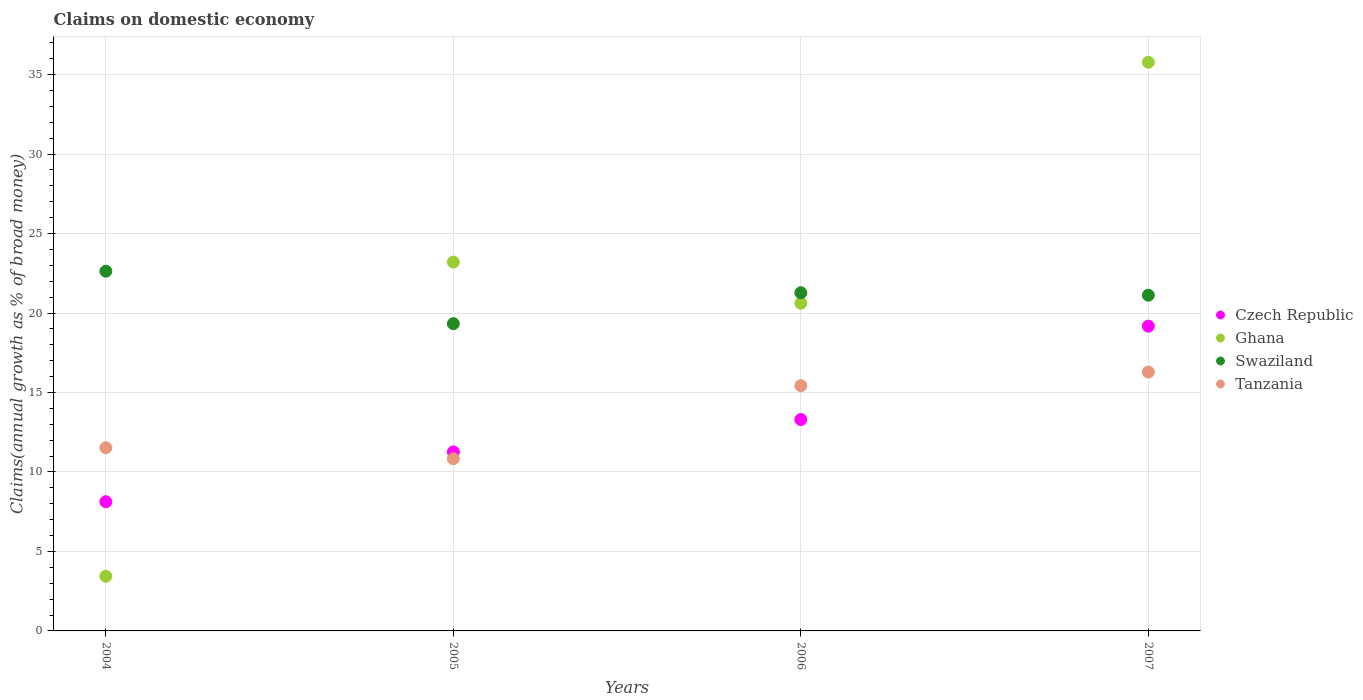How many different coloured dotlines are there?
Ensure brevity in your answer.  4. What is the percentage of broad money claimed on domestic economy in Ghana in 2007?
Your answer should be compact. 35.77. Across all years, what is the maximum percentage of broad money claimed on domestic economy in Tanzania?
Give a very brief answer. 16.29. Across all years, what is the minimum percentage of broad money claimed on domestic economy in Tanzania?
Your answer should be very brief. 10.83. What is the total percentage of broad money claimed on domestic economy in Ghana in the graph?
Provide a short and direct response. 83.03. What is the difference between the percentage of broad money claimed on domestic economy in Ghana in 2005 and that in 2006?
Provide a short and direct response. 2.59. What is the difference between the percentage of broad money claimed on domestic economy in Swaziland in 2006 and the percentage of broad money claimed on domestic economy in Czech Republic in 2004?
Your answer should be very brief. 13.15. What is the average percentage of broad money claimed on domestic economy in Swaziland per year?
Offer a very short reply. 21.09. In the year 2007, what is the difference between the percentage of broad money claimed on domestic economy in Ghana and percentage of broad money claimed on domestic economy in Swaziland?
Keep it short and to the point. 14.65. What is the ratio of the percentage of broad money claimed on domestic economy in Tanzania in 2005 to that in 2006?
Make the answer very short. 0.7. Is the difference between the percentage of broad money claimed on domestic economy in Ghana in 2004 and 2005 greater than the difference between the percentage of broad money claimed on domestic economy in Swaziland in 2004 and 2005?
Make the answer very short. No. What is the difference between the highest and the second highest percentage of broad money claimed on domestic economy in Czech Republic?
Offer a terse response. 5.87. What is the difference between the highest and the lowest percentage of broad money claimed on domestic economy in Czech Republic?
Ensure brevity in your answer.  11.05. In how many years, is the percentage of broad money claimed on domestic economy in Czech Republic greater than the average percentage of broad money claimed on domestic economy in Czech Republic taken over all years?
Offer a very short reply. 2. Is the sum of the percentage of broad money claimed on domestic economy in Tanzania in 2004 and 2006 greater than the maximum percentage of broad money claimed on domestic economy in Czech Republic across all years?
Offer a very short reply. Yes. Is it the case that in every year, the sum of the percentage of broad money claimed on domestic economy in Tanzania and percentage of broad money claimed on domestic economy in Swaziland  is greater than the percentage of broad money claimed on domestic economy in Ghana?
Provide a succinct answer. Yes. Is the percentage of broad money claimed on domestic economy in Tanzania strictly less than the percentage of broad money claimed on domestic economy in Czech Republic over the years?
Your response must be concise. No. What is the difference between two consecutive major ticks on the Y-axis?
Your answer should be compact. 5. Are the values on the major ticks of Y-axis written in scientific E-notation?
Provide a short and direct response. No. Does the graph contain any zero values?
Offer a very short reply. No. How many legend labels are there?
Offer a terse response. 4. How are the legend labels stacked?
Your response must be concise. Vertical. What is the title of the graph?
Provide a short and direct response. Claims on domestic economy. Does "East Asia (developing only)" appear as one of the legend labels in the graph?
Keep it short and to the point. No. What is the label or title of the X-axis?
Your answer should be very brief. Years. What is the label or title of the Y-axis?
Ensure brevity in your answer.  Claims(annual growth as % of broad money). What is the Claims(annual growth as % of broad money) in Czech Republic in 2004?
Your response must be concise. 8.13. What is the Claims(annual growth as % of broad money) in Ghana in 2004?
Give a very brief answer. 3.44. What is the Claims(annual growth as % of broad money) of Swaziland in 2004?
Give a very brief answer. 22.63. What is the Claims(annual growth as % of broad money) in Tanzania in 2004?
Your answer should be very brief. 11.52. What is the Claims(annual growth as % of broad money) in Czech Republic in 2005?
Provide a succinct answer. 11.26. What is the Claims(annual growth as % of broad money) in Ghana in 2005?
Ensure brevity in your answer.  23.2. What is the Claims(annual growth as % of broad money) of Swaziland in 2005?
Ensure brevity in your answer.  19.33. What is the Claims(annual growth as % of broad money) of Tanzania in 2005?
Your answer should be compact. 10.83. What is the Claims(annual growth as % of broad money) of Czech Republic in 2006?
Give a very brief answer. 13.3. What is the Claims(annual growth as % of broad money) of Ghana in 2006?
Offer a very short reply. 20.62. What is the Claims(annual growth as % of broad money) in Swaziland in 2006?
Provide a succinct answer. 21.27. What is the Claims(annual growth as % of broad money) of Tanzania in 2006?
Offer a very short reply. 15.43. What is the Claims(annual growth as % of broad money) in Czech Republic in 2007?
Offer a terse response. 19.17. What is the Claims(annual growth as % of broad money) in Ghana in 2007?
Make the answer very short. 35.77. What is the Claims(annual growth as % of broad money) in Swaziland in 2007?
Give a very brief answer. 21.12. What is the Claims(annual growth as % of broad money) in Tanzania in 2007?
Your answer should be very brief. 16.29. Across all years, what is the maximum Claims(annual growth as % of broad money) of Czech Republic?
Your response must be concise. 19.17. Across all years, what is the maximum Claims(annual growth as % of broad money) of Ghana?
Your answer should be very brief. 35.77. Across all years, what is the maximum Claims(annual growth as % of broad money) in Swaziland?
Provide a short and direct response. 22.63. Across all years, what is the maximum Claims(annual growth as % of broad money) of Tanzania?
Provide a succinct answer. 16.29. Across all years, what is the minimum Claims(annual growth as % of broad money) in Czech Republic?
Your response must be concise. 8.13. Across all years, what is the minimum Claims(annual growth as % of broad money) of Ghana?
Give a very brief answer. 3.44. Across all years, what is the minimum Claims(annual growth as % of broad money) in Swaziland?
Your answer should be very brief. 19.33. Across all years, what is the minimum Claims(annual growth as % of broad money) in Tanzania?
Your answer should be compact. 10.83. What is the total Claims(annual growth as % of broad money) in Czech Republic in the graph?
Your answer should be very brief. 51.86. What is the total Claims(annual growth as % of broad money) of Ghana in the graph?
Make the answer very short. 83.03. What is the total Claims(annual growth as % of broad money) of Swaziland in the graph?
Offer a very short reply. 84.35. What is the total Claims(annual growth as % of broad money) in Tanzania in the graph?
Your answer should be compact. 54.07. What is the difference between the Claims(annual growth as % of broad money) in Czech Republic in 2004 and that in 2005?
Make the answer very short. -3.14. What is the difference between the Claims(annual growth as % of broad money) in Ghana in 2004 and that in 2005?
Keep it short and to the point. -19.76. What is the difference between the Claims(annual growth as % of broad money) in Swaziland in 2004 and that in 2005?
Provide a succinct answer. 3.3. What is the difference between the Claims(annual growth as % of broad money) of Tanzania in 2004 and that in 2005?
Offer a very short reply. 0.69. What is the difference between the Claims(annual growth as % of broad money) of Czech Republic in 2004 and that in 2006?
Ensure brevity in your answer.  -5.17. What is the difference between the Claims(annual growth as % of broad money) of Ghana in 2004 and that in 2006?
Offer a terse response. -17.18. What is the difference between the Claims(annual growth as % of broad money) in Swaziland in 2004 and that in 2006?
Ensure brevity in your answer.  1.35. What is the difference between the Claims(annual growth as % of broad money) in Tanzania in 2004 and that in 2006?
Give a very brief answer. -3.91. What is the difference between the Claims(annual growth as % of broad money) in Czech Republic in 2004 and that in 2007?
Your answer should be very brief. -11.05. What is the difference between the Claims(annual growth as % of broad money) in Ghana in 2004 and that in 2007?
Your answer should be very brief. -32.33. What is the difference between the Claims(annual growth as % of broad money) in Swaziland in 2004 and that in 2007?
Your answer should be very brief. 1.51. What is the difference between the Claims(annual growth as % of broad money) of Tanzania in 2004 and that in 2007?
Offer a terse response. -4.76. What is the difference between the Claims(annual growth as % of broad money) in Czech Republic in 2005 and that in 2006?
Make the answer very short. -2.04. What is the difference between the Claims(annual growth as % of broad money) of Ghana in 2005 and that in 2006?
Provide a short and direct response. 2.59. What is the difference between the Claims(annual growth as % of broad money) of Swaziland in 2005 and that in 2006?
Provide a succinct answer. -1.95. What is the difference between the Claims(annual growth as % of broad money) of Tanzania in 2005 and that in 2006?
Make the answer very short. -4.6. What is the difference between the Claims(annual growth as % of broad money) in Czech Republic in 2005 and that in 2007?
Give a very brief answer. -7.91. What is the difference between the Claims(annual growth as % of broad money) in Ghana in 2005 and that in 2007?
Offer a very short reply. -12.57. What is the difference between the Claims(annual growth as % of broad money) of Swaziland in 2005 and that in 2007?
Ensure brevity in your answer.  -1.79. What is the difference between the Claims(annual growth as % of broad money) in Tanzania in 2005 and that in 2007?
Keep it short and to the point. -5.46. What is the difference between the Claims(annual growth as % of broad money) in Czech Republic in 2006 and that in 2007?
Offer a very short reply. -5.87. What is the difference between the Claims(annual growth as % of broad money) in Ghana in 2006 and that in 2007?
Provide a short and direct response. -15.16. What is the difference between the Claims(annual growth as % of broad money) in Swaziland in 2006 and that in 2007?
Ensure brevity in your answer.  0.15. What is the difference between the Claims(annual growth as % of broad money) in Tanzania in 2006 and that in 2007?
Provide a succinct answer. -0.86. What is the difference between the Claims(annual growth as % of broad money) of Czech Republic in 2004 and the Claims(annual growth as % of broad money) of Ghana in 2005?
Your response must be concise. -15.08. What is the difference between the Claims(annual growth as % of broad money) in Czech Republic in 2004 and the Claims(annual growth as % of broad money) in Swaziland in 2005?
Provide a short and direct response. -11.2. What is the difference between the Claims(annual growth as % of broad money) in Czech Republic in 2004 and the Claims(annual growth as % of broad money) in Tanzania in 2005?
Provide a short and direct response. -2.7. What is the difference between the Claims(annual growth as % of broad money) in Ghana in 2004 and the Claims(annual growth as % of broad money) in Swaziland in 2005?
Make the answer very short. -15.89. What is the difference between the Claims(annual growth as % of broad money) of Ghana in 2004 and the Claims(annual growth as % of broad money) of Tanzania in 2005?
Your response must be concise. -7.39. What is the difference between the Claims(annual growth as % of broad money) of Swaziland in 2004 and the Claims(annual growth as % of broad money) of Tanzania in 2005?
Your answer should be very brief. 11.8. What is the difference between the Claims(annual growth as % of broad money) in Czech Republic in 2004 and the Claims(annual growth as % of broad money) in Ghana in 2006?
Provide a succinct answer. -12.49. What is the difference between the Claims(annual growth as % of broad money) in Czech Republic in 2004 and the Claims(annual growth as % of broad money) in Swaziland in 2006?
Give a very brief answer. -13.15. What is the difference between the Claims(annual growth as % of broad money) of Czech Republic in 2004 and the Claims(annual growth as % of broad money) of Tanzania in 2006?
Keep it short and to the point. -7.3. What is the difference between the Claims(annual growth as % of broad money) in Ghana in 2004 and the Claims(annual growth as % of broad money) in Swaziland in 2006?
Offer a terse response. -17.84. What is the difference between the Claims(annual growth as % of broad money) of Ghana in 2004 and the Claims(annual growth as % of broad money) of Tanzania in 2006?
Offer a very short reply. -11.99. What is the difference between the Claims(annual growth as % of broad money) of Swaziland in 2004 and the Claims(annual growth as % of broad money) of Tanzania in 2006?
Provide a succinct answer. 7.2. What is the difference between the Claims(annual growth as % of broad money) in Czech Republic in 2004 and the Claims(annual growth as % of broad money) in Ghana in 2007?
Provide a succinct answer. -27.65. What is the difference between the Claims(annual growth as % of broad money) of Czech Republic in 2004 and the Claims(annual growth as % of broad money) of Swaziland in 2007?
Provide a short and direct response. -12.99. What is the difference between the Claims(annual growth as % of broad money) in Czech Republic in 2004 and the Claims(annual growth as % of broad money) in Tanzania in 2007?
Give a very brief answer. -8.16. What is the difference between the Claims(annual growth as % of broad money) in Ghana in 2004 and the Claims(annual growth as % of broad money) in Swaziland in 2007?
Give a very brief answer. -17.68. What is the difference between the Claims(annual growth as % of broad money) of Ghana in 2004 and the Claims(annual growth as % of broad money) of Tanzania in 2007?
Give a very brief answer. -12.85. What is the difference between the Claims(annual growth as % of broad money) in Swaziland in 2004 and the Claims(annual growth as % of broad money) in Tanzania in 2007?
Your response must be concise. 6.34. What is the difference between the Claims(annual growth as % of broad money) of Czech Republic in 2005 and the Claims(annual growth as % of broad money) of Ghana in 2006?
Provide a short and direct response. -9.36. What is the difference between the Claims(annual growth as % of broad money) of Czech Republic in 2005 and the Claims(annual growth as % of broad money) of Swaziland in 2006?
Provide a succinct answer. -10.01. What is the difference between the Claims(annual growth as % of broad money) in Czech Republic in 2005 and the Claims(annual growth as % of broad money) in Tanzania in 2006?
Give a very brief answer. -4.17. What is the difference between the Claims(annual growth as % of broad money) of Ghana in 2005 and the Claims(annual growth as % of broad money) of Swaziland in 2006?
Make the answer very short. 1.93. What is the difference between the Claims(annual growth as % of broad money) of Ghana in 2005 and the Claims(annual growth as % of broad money) of Tanzania in 2006?
Ensure brevity in your answer.  7.77. What is the difference between the Claims(annual growth as % of broad money) in Swaziland in 2005 and the Claims(annual growth as % of broad money) in Tanzania in 2006?
Offer a terse response. 3.9. What is the difference between the Claims(annual growth as % of broad money) in Czech Republic in 2005 and the Claims(annual growth as % of broad money) in Ghana in 2007?
Keep it short and to the point. -24.51. What is the difference between the Claims(annual growth as % of broad money) in Czech Republic in 2005 and the Claims(annual growth as % of broad money) in Swaziland in 2007?
Give a very brief answer. -9.86. What is the difference between the Claims(annual growth as % of broad money) in Czech Republic in 2005 and the Claims(annual growth as % of broad money) in Tanzania in 2007?
Ensure brevity in your answer.  -5.02. What is the difference between the Claims(annual growth as % of broad money) of Ghana in 2005 and the Claims(annual growth as % of broad money) of Swaziland in 2007?
Your answer should be compact. 2.08. What is the difference between the Claims(annual growth as % of broad money) in Ghana in 2005 and the Claims(annual growth as % of broad money) in Tanzania in 2007?
Make the answer very short. 6.92. What is the difference between the Claims(annual growth as % of broad money) of Swaziland in 2005 and the Claims(annual growth as % of broad money) of Tanzania in 2007?
Your answer should be very brief. 3.04. What is the difference between the Claims(annual growth as % of broad money) in Czech Republic in 2006 and the Claims(annual growth as % of broad money) in Ghana in 2007?
Ensure brevity in your answer.  -22.47. What is the difference between the Claims(annual growth as % of broad money) of Czech Republic in 2006 and the Claims(annual growth as % of broad money) of Swaziland in 2007?
Provide a short and direct response. -7.82. What is the difference between the Claims(annual growth as % of broad money) in Czech Republic in 2006 and the Claims(annual growth as % of broad money) in Tanzania in 2007?
Your answer should be very brief. -2.99. What is the difference between the Claims(annual growth as % of broad money) of Ghana in 2006 and the Claims(annual growth as % of broad money) of Swaziland in 2007?
Provide a short and direct response. -0.5. What is the difference between the Claims(annual growth as % of broad money) in Ghana in 2006 and the Claims(annual growth as % of broad money) in Tanzania in 2007?
Give a very brief answer. 4.33. What is the difference between the Claims(annual growth as % of broad money) in Swaziland in 2006 and the Claims(annual growth as % of broad money) in Tanzania in 2007?
Make the answer very short. 4.99. What is the average Claims(annual growth as % of broad money) in Czech Republic per year?
Your answer should be very brief. 12.96. What is the average Claims(annual growth as % of broad money) of Ghana per year?
Offer a very short reply. 20.76. What is the average Claims(annual growth as % of broad money) in Swaziland per year?
Your response must be concise. 21.09. What is the average Claims(annual growth as % of broad money) of Tanzania per year?
Provide a succinct answer. 13.52. In the year 2004, what is the difference between the Claims(annual growth as % of broad money) in Czech Republic and Claims(annual growth as % of broad money) in Ghana?
Your response must be concise. 4.69. In the year 2004, what is the difference between the Claims(annual growth as % of broad money) in Czech Republic and Claims(annual growth as % of broad money) in Swaziland?
Ensure brevity in your answer.  -14.5. In the year 2004, what is the difference between the Claims(annual growth as % of broad money) of Czech Republic and Claims(annual growth as % of broad money) of Tanzania?
Make the answer very short. -3.4. In the year 2004, what is the difference between the Claims(annual growth as % of broad money) of Ghana and Claims(annual growth as % of broad money) of Swaziland?
Offer a terse response. -19.19. In the year 2004, what is the difference between the Claims(annual growth as % of broad money) in Ghana and Claims(annual growth as % of broad money) in Tanzania?
Provide a short and direct response. -8.08. In the year 2004, what is the difference between the Claims(annual growth as % of broad money) of Swaziland and Claims(annual growth as % of broad money) of Tanzania?
Make the answer very short. 11.1. In the year 2005, what is the difference between the Claims(annual growth as % of broad money) in Czech Republic and Claims(annual growth as % of broad money) in Ghana?
Ensure brevity in your answer.  -11.94. In the year 2005, what is the difference between the Claims(annual growth as % of broad money) of Czech Republic and Claims(annual growth as % of broad money) of Swaziland?
Keep it short and to the point. -8.07. In the year 2005, what is the difference between the Claims(annual growth as % of broad money) in Czech Republic and Claims(annual growth as % of broad money) in Tanzania?
Your response must be concise. 0.43. In the year 2005, what is the difference between the Claims(annual growth as % of broad money) of Ghana and Claims(annual growth as % of broad money) of Swaziland?
Offer a very short reply. 3.87. In the year 2005, what is the difference between the Claims(annual growth as % of broad money) of Ghana and Claims(annual growth as % of broad money) of Tanzania?
Your answer should be compact. 12.37. In the year 2005, what is the difference between the Claims(annual growth as % of broad money) of Swaziland and Claims(annual growth as % of broad money) of Tanzania?
Provide a short and direct response. 8.5. In the year 2006, what is the difference between the Claims(annual growth as % of broad money) in Czech Republic and Claims(annual growth as % of broad money) in Ghana?
Provide a short and direct response. -7.32. In the year 2006, what is the difference between the Claims(annual growth as % of broad money) of Czech Republic and Claims(annual growth as % of broad money) of Swaziland?
Your response must be concise. -7.98. In the year 2006, what is the difference between the Claims(annual growth as % of broad money) of Czech Republic and Claims(annual growth as % of broad money) of Tanzania?
Give a very brief answer. -2.13. In the year 2006, what is the difference between the Claims(annual growth as % of broad money) in Ghana and Claims(annual growth as % of broad money) in Swaziland?
Provide a short and direct response. -0.66. In the year 2006, what is the difference between the Claims(annual growth as % of broad money) of Ghana and Claims(annual growth as % of broad money) of Tanzania?
Offer a very short reply. 5.19. In the year 2006, what is the difference between the Claims(annual growth as % of broad money) of Swaziland and Claims(annual growth as % of broad money) of Tanzania?
Ensure brevity in your answer.  5.85. In the year 2007, what is the difference between the Claims(annual growth as % of broad money) of Czech Republic and Claims(annual growth as % of broad money) of Ghana?
Make the answer very short. -16.6. In the year 2007, what is the difference between the Claims(annual growth as % of broad money) in Czech Republic and Claims(annual growth as % of broad money) in Swaziland?
Ensure brevity in your answer.  -1.95. In the year 2007, what is the difference between the Claims(annual growth as % of broad money) in Czech Republic and Claims(annual growth as % of broad money) in Tanzania?
Provide a succinct answer. 2.89. In the year 2007, what is the difference between the Claims(annual growth as % of broad money) in Ghana and Claims(annual growth as % of broad money) in Swaziland?
Your answer should be very brief. 14.65. In the year 2007, what is the difference between the Claims(annual growth as % of broad money) of Ghana and Claims(annual growth as % of broad money) of Tanzania?
Give a very brief answer. 19.49. In the year 2007, what is the difference between the Claims(annual growth as % of broad money) in Swaziland and Claims(annual growth as % of broad money) in Tanzania?
Provide a succinct answer. 4.83. What is the ratio of the Claims(annual growth as % of broad money) of Czech Republic in 2004 to that in 2005?
Provide a short and direct response. 0.72. What is the ratio of the Claims(annual growth as % of broad money) of Ghana in 2004 to that in 2005?
Your answer should be compact. 0.15. What is the ratio of the Claims(annual growth as % of broad money) of Swaziland in 2004 to that in 2005?
Make the answer very short. 1.17. What is the ratio of the Claims(annual growth as % of broad money) in Tanzania in 2004 to that in 2005?
Give a very brief answer. 1.06. What is the ratio of the Claims(annual growth as % of broad money) of Czech Republic in 2004 to that in 2006?
Provide a short and direct response. 0.61. What is the ratio of the Claims(annual growth as % of broad money) of Ghana in 2004 to that in 2006?
Your response must be concise. 0.17. What is the ratio of the Claims(annual growth as % of broad money) in Swaziland in 2004 to that in 2006?
Your answer should be compact. 1.06. What is the ratio of the Claims(annual growth as % of broad money) in Tanzania in 2004 to that in 2006?
Your response must be concise. 0.75. What is the ratio of the Claims(annual growth as % of broad money) of Czech Republic in 2004 to that in 2007?
Give a very brief answer. 0.42. What is the ratio of the Claims(annual growth as % of broad money) in Ghana in 2004 to that in 2007?
Your answer should be compact. 0.1. What is the ratio of the Claims(annual growth as % of broad money) in Swaziland in 2004 to that in 2007?
Your answer should be very brief. 1.07. What is the ratio of the Claims(annual growth as % of broad money) in Tanzania in 2004 to that in 2007?
Make the answer very short. 0.71. What is the ratio of the Claims(annual growth as % of broad money) in Czech Republic in 2005 to that in 2006?
Make the answer very short. 0.85. What is the ratio of the Claims(annual growth as % of broad money) in Ghana in 2005 to that in 2006?
Your answer should be very brief. 1.13. What is the ratio of the Claims(annual growth as % of broad money) of Swaziland in 2005 to that in 2006?
Give a very brief answer. 0.91. What is the ratio of the Claims(annual growth as % of broad money) of Tanzania in 2005 to that in 2006?
Keep it short and to the point. 0.7. What is the ratio of the Claims(annual growth as % of broad money) in Czech Republic in 2005 to that in 2007?
Your answer should be compact. 0.59. What is the ratio of the Claims(annual growth as % of broad money) in Ghana in 2005 to that in 2007?
Offer a very short reply. 0.65. What is the ratio of the Claims(annual growth as % of broad money) of Swaziland in 2005 to that in 2007?
Offer a terse response. 0.92. What is the ratio of the Claims(annual growth as % of broad money) of Tanzania in 2005 to that in 2007?
Keep it short and to the point. 0.67. What is the ratio of the Claims(annual growth as % of broad money) of Czech Republic in 2006 to that in 2007?
Make the answer very short. 0.69. What is the ratio of the Claims(annual growth as % of broad money) of Ghana in 2006 to that in 2007?
Make the answer very short. 0.58. What is the ratio of the Claims(annual growth as % of broad money) in Swaziland in 2006 to that in 2007?
Your answer should be very brief. 1.01. What is the ratio of the Claims(annual growth as % of broad money) in Tanzania in 2006 to that in 2007?
Your answer should be compact. 0.95. What is the difference between the highest and the second highest Claims(annual growth as % of broad money) of Czech Republic?
Give a very brief answer. 5.87. What is the difference between the highest and the second highest Claims(annual growth as % of broad money) of Ghana?
Your response must be concise. 12.57. What is the difference between the highest and the second highest Claims(annual growth as % of broad money) in Swaziland?
Your answer should be compact. 1.35. What is the difference between the highest and the second highest Claims(annual growth as % of broad money) of Tanzania?
Offer a very short reply. 0.86. What is the difference between the highest and the lowest Claims(annual growth as % of broad money) in Czech Republic?
Give a very brief answer. 11.05. What is the difference between the highest and the lowest Claims(annual growth as % of broad money) of Ghana?
Provide a succinct answer. 32.33. What is the difference between the highest and the lowest Claims(annual growth as % of broad money) in Swaziland?
Ensure brevity in your answer.  3.3. What is the difference between the highest and the lowest Claims(annual growth as % of broad money) of Tanzania?
Provide a succinct answer. 5.46. 